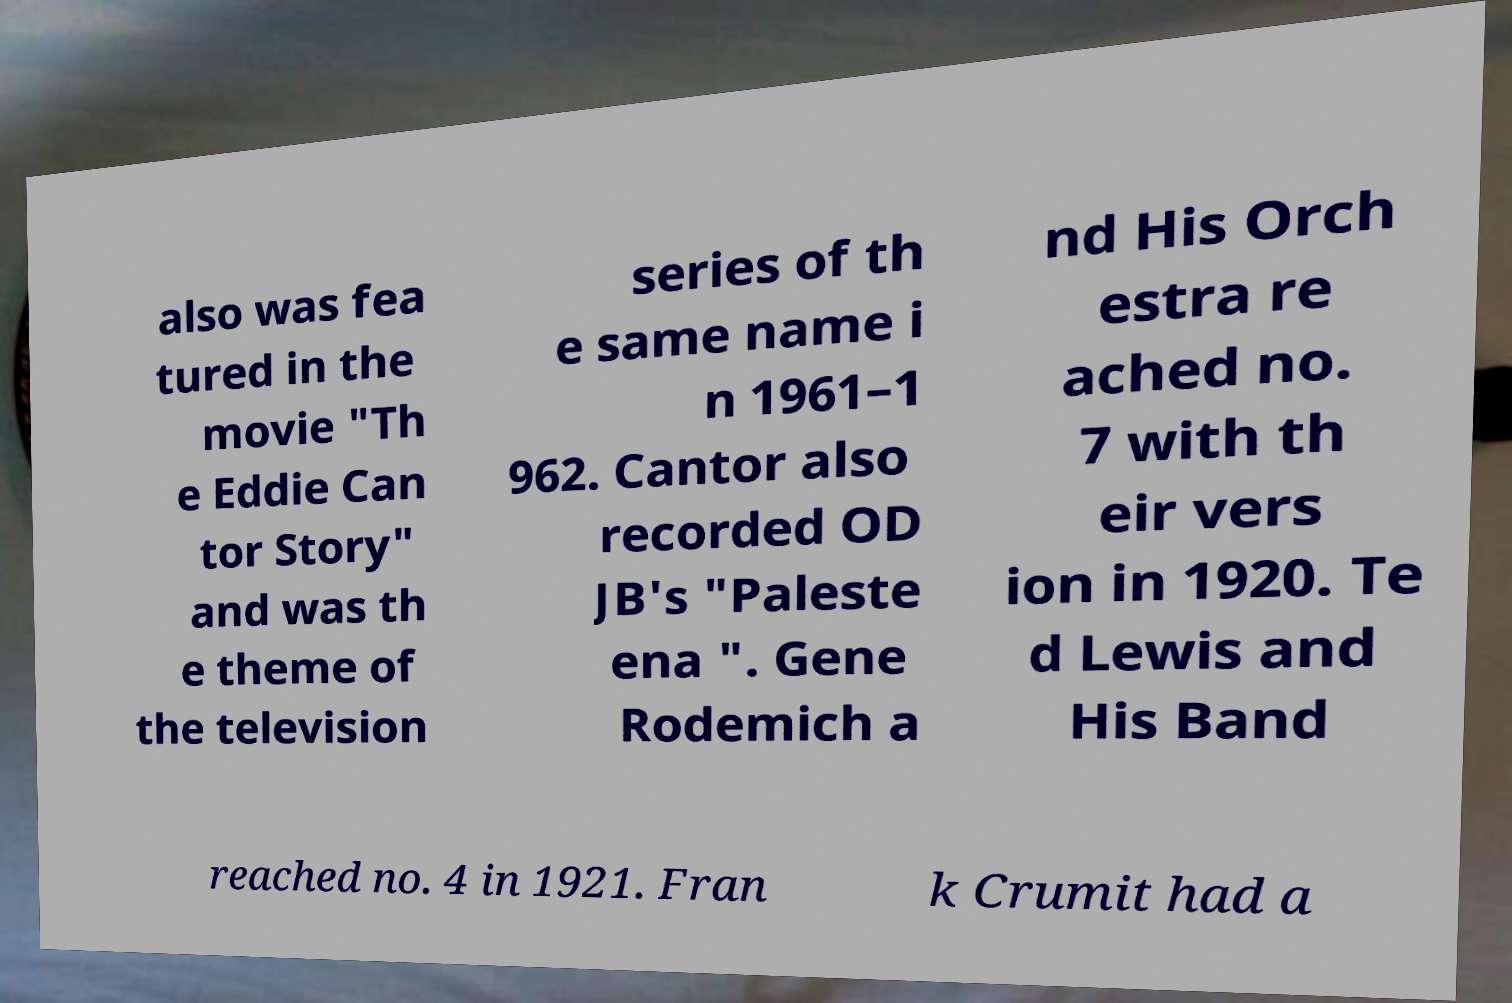Can you accurately transcribe the text from the provided image for me? also was fea tured in the movie "Th e Eddie Can tor Story" and was th e theme of the television series of th e same name i n 1961–1 962. Cantor also recorded OD JB's "Paleste ena ". Gene Rodemich a nd His Orch estra re ached no. 7 with th eir vers ion in 1920. Te d Lewis and His Band reached no. 4 in 1921. Fran k Crumit had a 